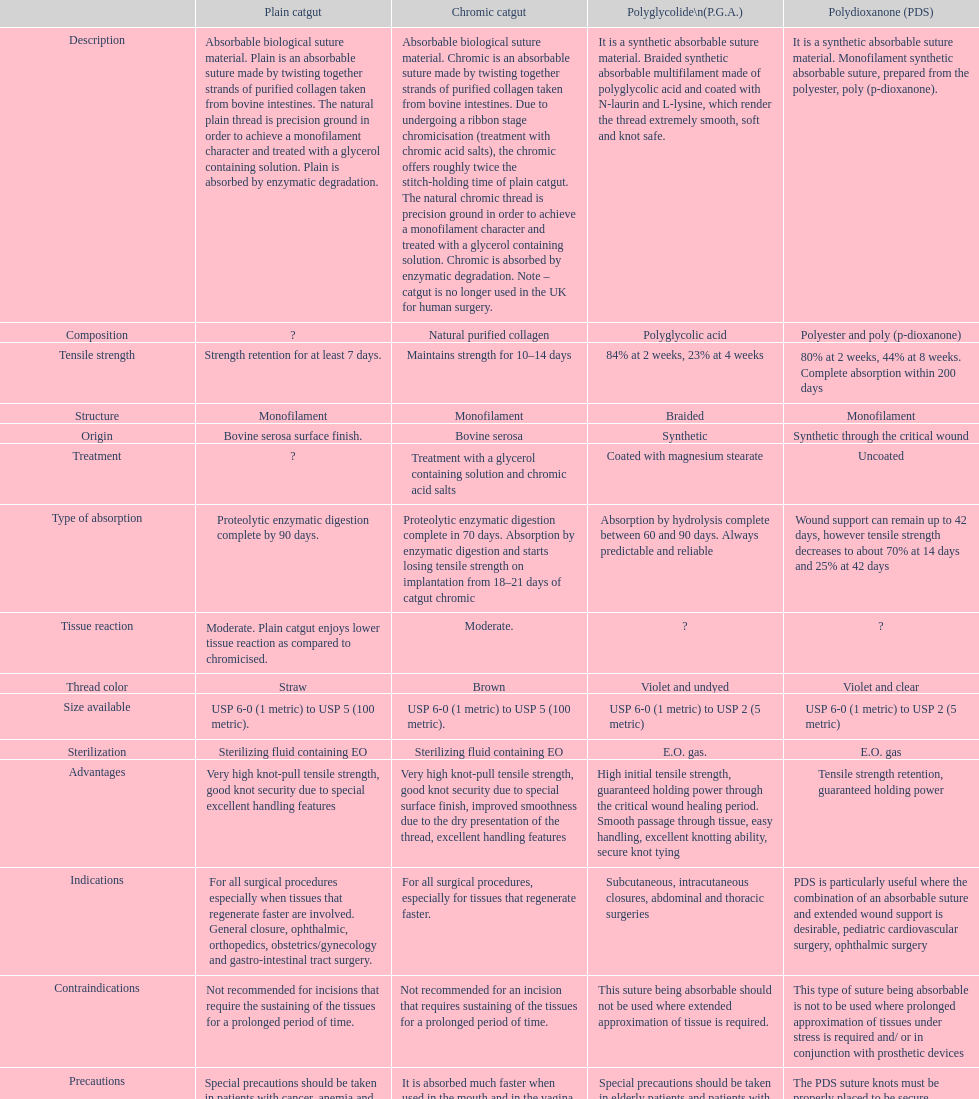In the uk, what category of sutures is no longer employed for surgical procedures on humans? Chromic catgut. 